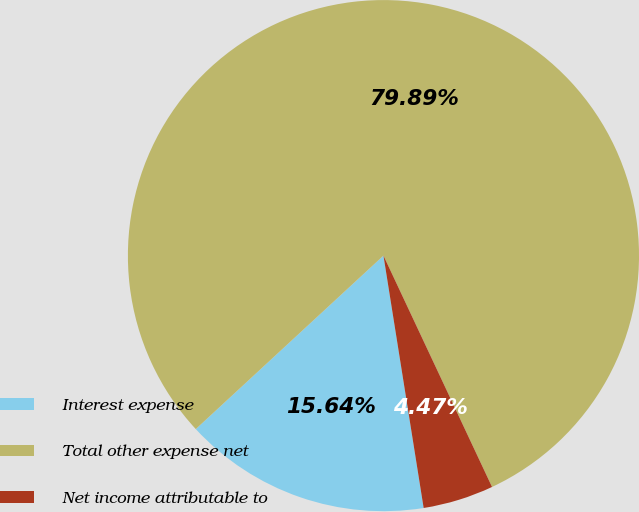<chart> <loc_0><loc_0><loc_500><loc_500><pie_chart><fcel>Interest expense<fcel>Total other expense net<fcel>Net income attributable to<nl><fcel>15.64%<fcel>79.89%<fcel>4.47%<nl></chart> 